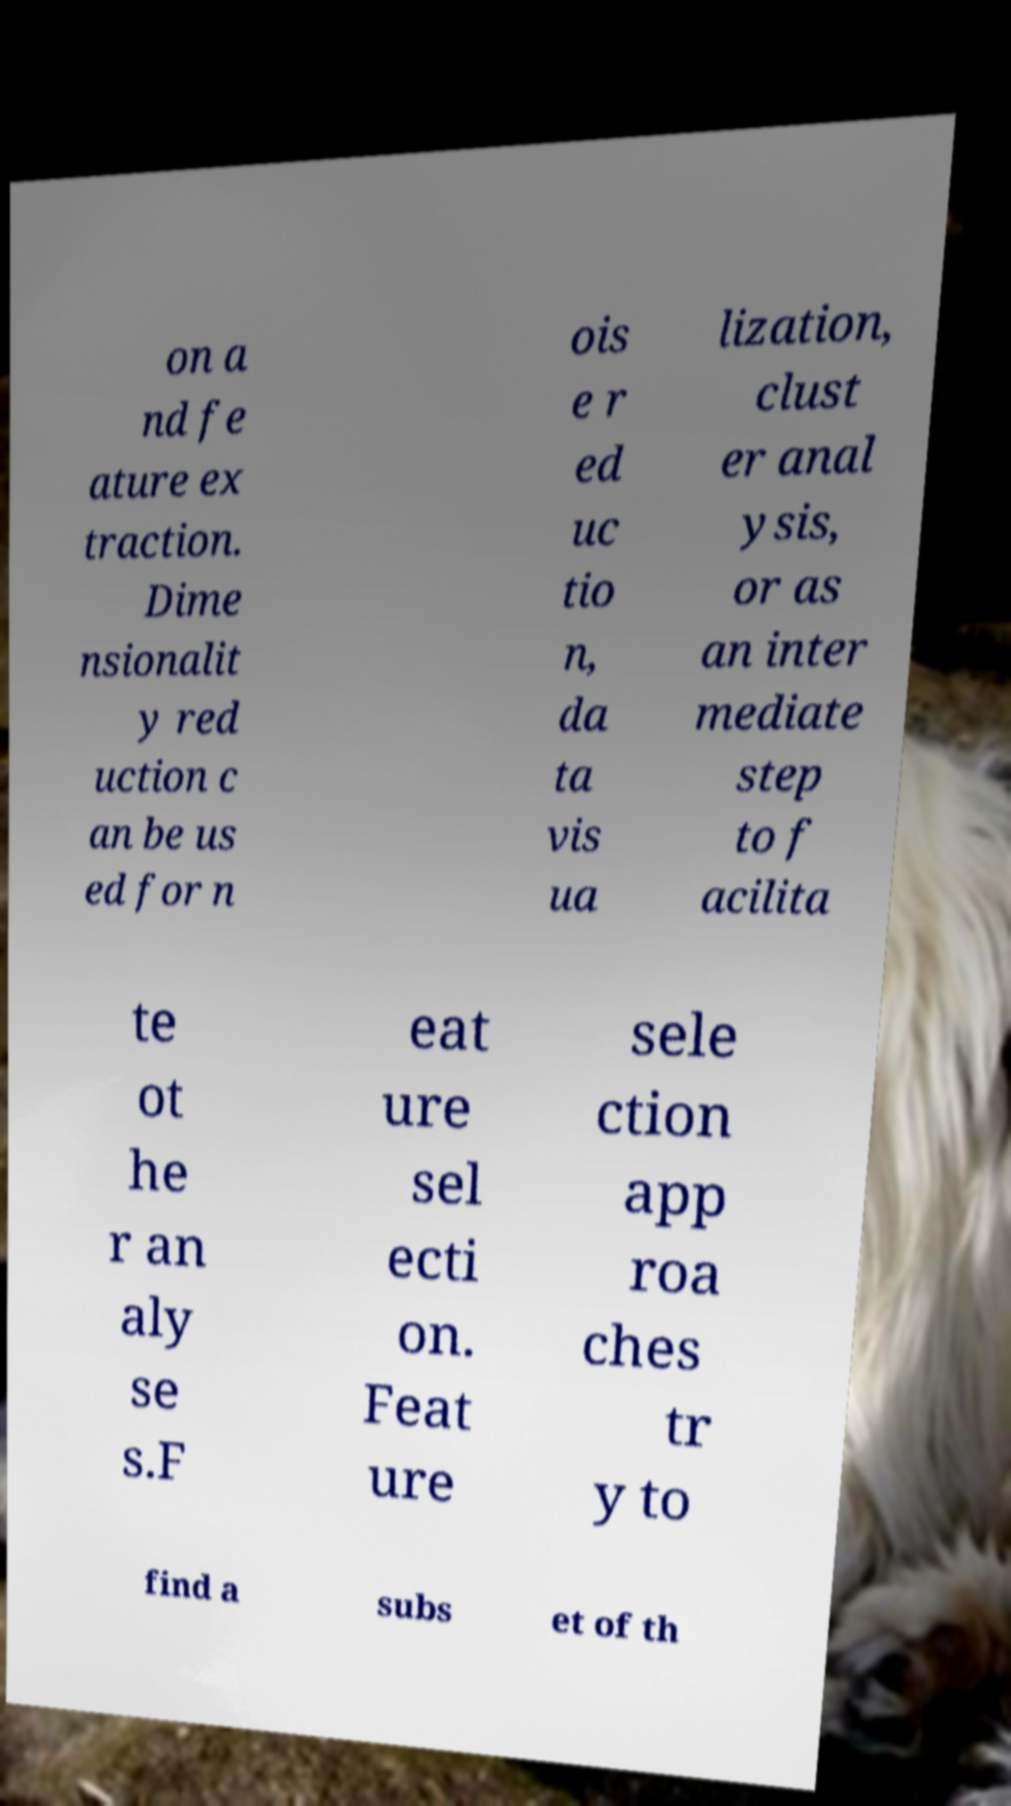Can you read and provide the text displayed in the image?This photo seems to have some interesting text. Can you extract and type it out for me? on a nd fe ature ex traction. Dime nsionalit y red uction c an be us ed for n ois e r ed uc tio n, da ta vis ua lization, clust er anal ysis, or as an inter mediate step to f acilita te ot he r an aly se s.F eat ure sel ecti on. Feat ure sele ction app roa ches tr y to find a subs et of th 